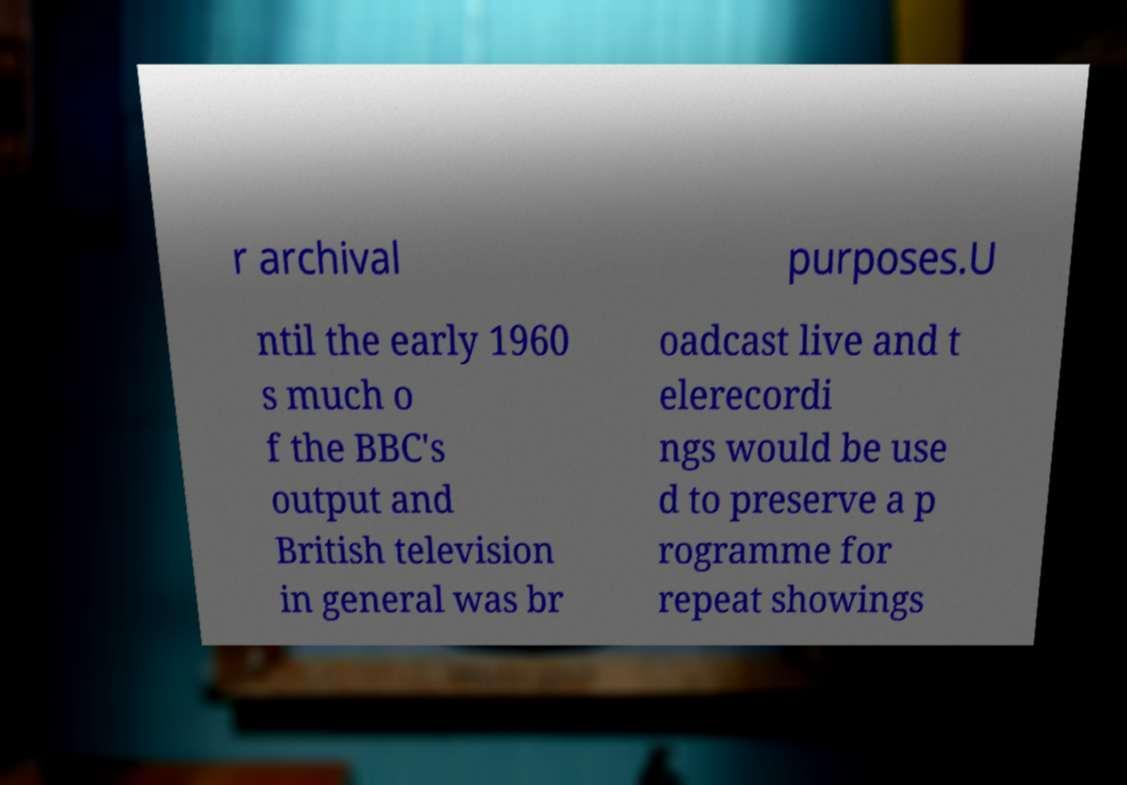I need the written content from this picture converted into text. Can you do that? r archival purposes.U ntil the early 1960 s much o f the BBC's output and British television in general was br oadcast live and t elerecordi ngs would be use d to preserve a p rogramme for repeat showings 